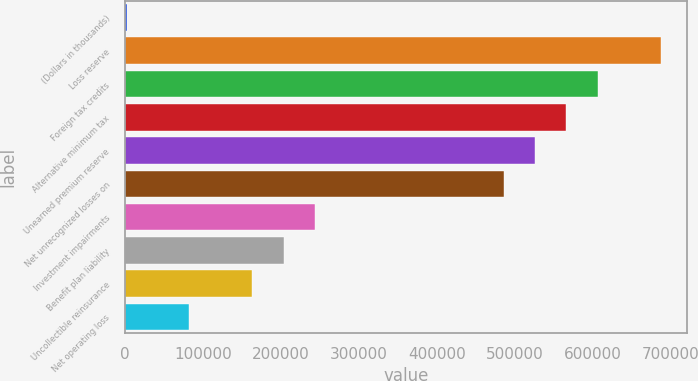Convert chart. <chart><loc_0><loc_0><loc_500><loc_500><bar_chart><fcel>(Dollars in thousands)<fcel>Loss reserve<fcel>Foreign tax credits<fcel>Alternative minimum tax<fcel>Unearned premium reserve<fcel>Net unrecognized losses on<fcel>Investment impairments<fcel>Benefit plan liability<fcel>Uncollectible reinsurance<fcel>Net operating loss<nl><fcel>2014<fcel>687369<fcel>606739<fcel>566424<fcel>526109<fcel>485794<fcel>243904<fcel>203589<fcel>163274<fcel>82644<nl></chart> 